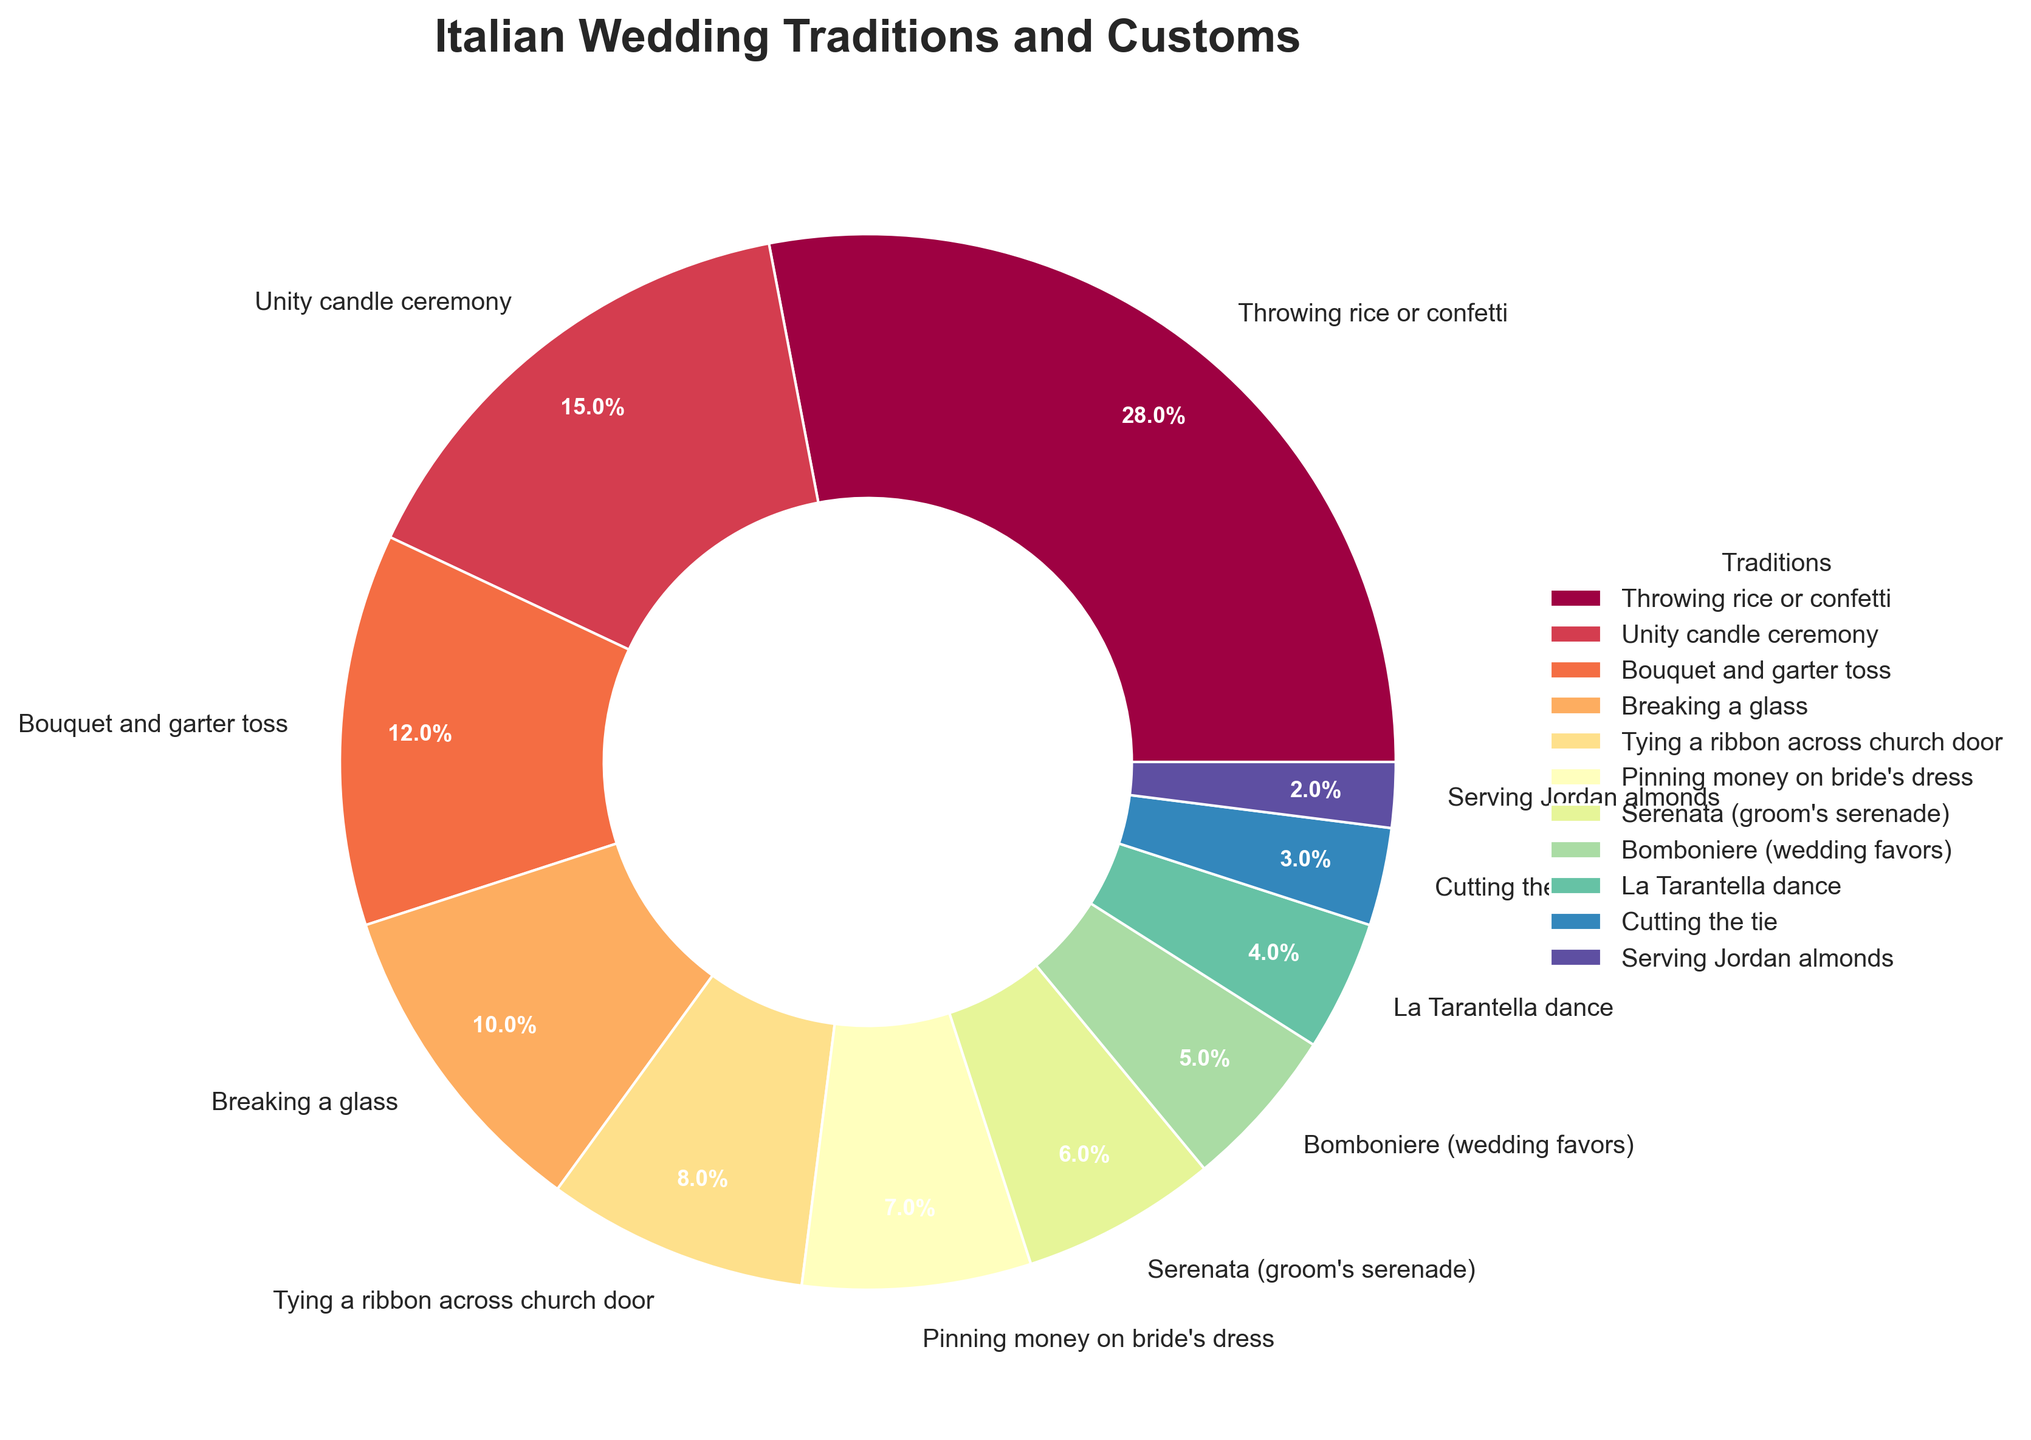Which tradition has the highest frequency? By looking at the pie chart, identify which segment is the largest and read its label. This segment will correspond to the tradition with the highest frequency.
Answer: Throwing rice or confetti Which tradition is more common: the bouquet and garter toss or breaking a glass? Compare the size of the pie chart segments labeled "Bouquet and garter toss" and "Breaking a glass". The larger segment represents the more common tradition.
Answer: Bouquet and garter toss What is the combined frequency of the traditions "Tying a ribbon across church door" and "Pinning money on bride's dress"? Find the frequency values for "Tying a ribbon across church door" (8) and "Pinning money on bride's dress" (7) and add them together.
Answer: 15 Which color represents the "Serenata (groom's serenade)" tradition? Identify the segment labeled "Serenata (groom's serenade)" and note its color from the pie chart.
Answer: [The color that matches the segment; this is context-dependent] What's the percentage of weddings that include the "Unity candle ceremony"? Find the "Unity candle ceremony" label and look at the percentage shown in the segment's annotation.
Answer: 15.0% How many traditions have a frequency of 5 or less? Count the segments in the pie chart with frequencies of 5 or less by referring to the labels and values provided.
Answer: 3 Which tradition has a similar frequency to "Unity candle ceremony"? Compare the frequencies and find the tradition with a frequency close to 15. The closest in this case is "Bouquet and garter toss" with a frequency of 12.
Answer: Bouquet and garter toss What's the difference in frequency between "Throwing rice or confetti" and "Bomboniere (wedding favors)"? Subtract the frequency of "Bomboniere (5)" from "Throwing rice or confetti" (28). Calculate: 28 - 5 = 23.
Answer: 23 Which traditions make up less than 10% of the total each? Look at the pie chart segments and find those that are annotated with less than 10%. These will be the smaller segments.
Answer: "Pinning money on bride's dress", "Serenata (groom's serenade)", "Bomboniere (wedding favors)", "La Tarantella dance", "Cutting the tie", and "Serving Jordan almonds" Is the frequency of "Serving Jordan almonds" more or less than half the frequency of "Breaking a glass"? Determine if the frequency of "Serving Jordan almonds" (2) is more or less than half of "Breaking a glass" (10 / 2 = 5). 2 is less than 5.
Answer: Less 